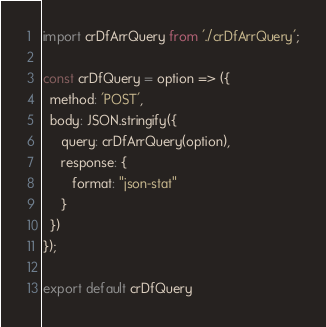<code> <loc_0><loc_0><loc_500><loc_500><_JavaScript_>import crDfArrQuery from './crDfArrQuery';

const crDfQuery = option => ({
  method: 'POST',
  body: JSON.stringify({
     query: crDfArrQuery(option),
     response: {
        format: "json-stat"
     }
  })
});

export default crDfQuery
</code> 